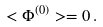Convert formula to latex. <formula><loc_0><loc_0><loc_500><loc_500>< \Phi ^ { ( 0 ) } > = 0 \, .</formula> 